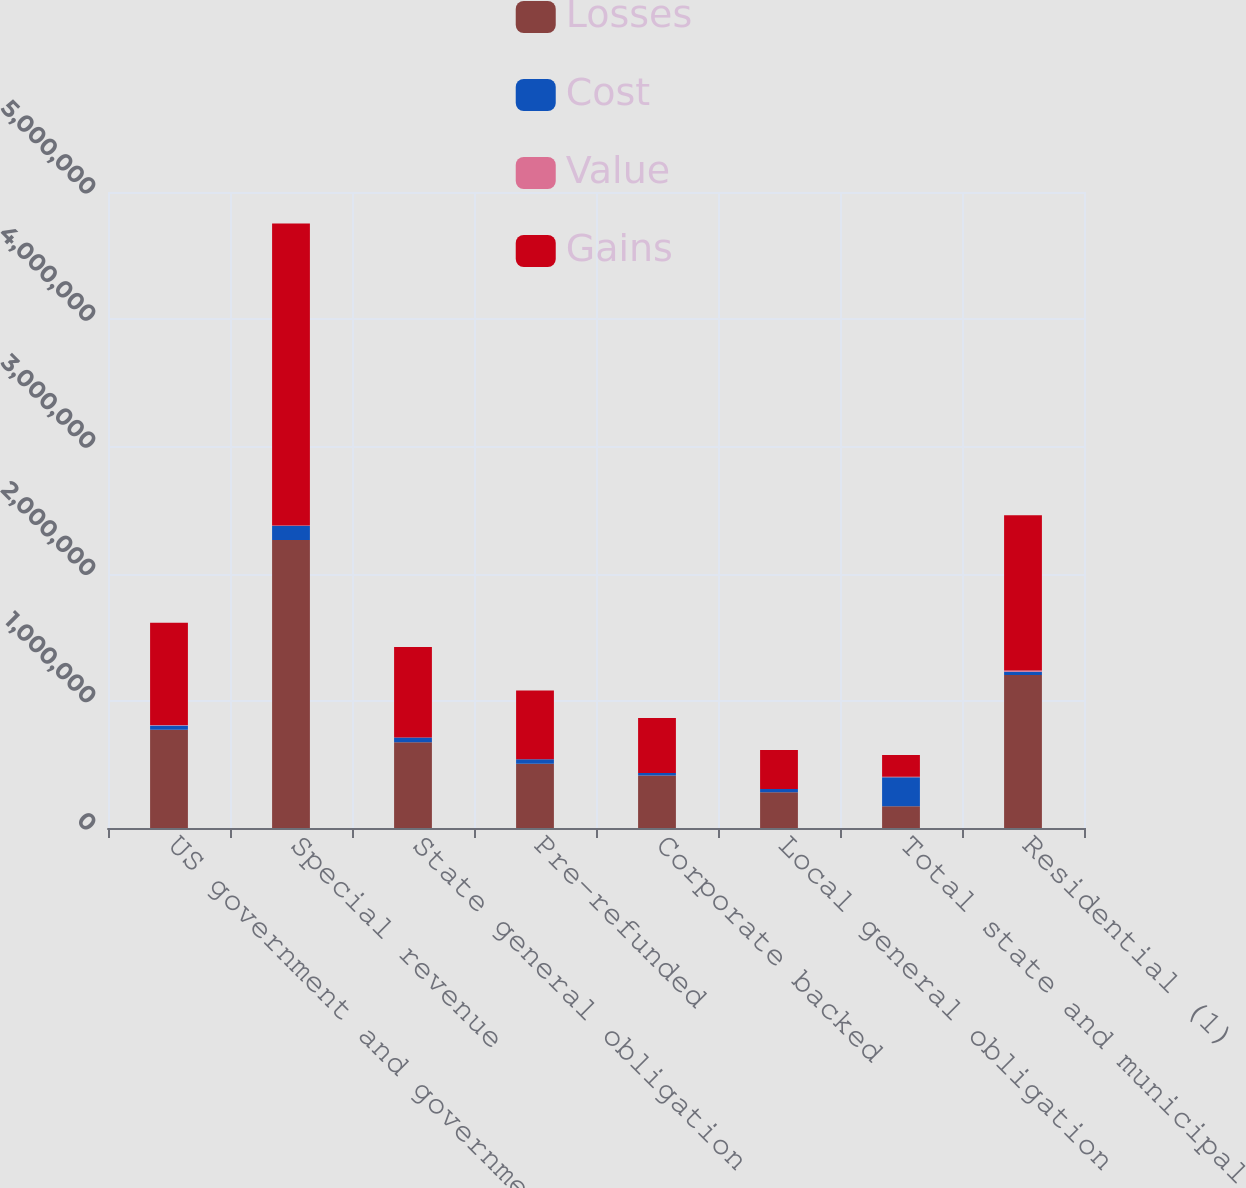Convert chart. <chart><loc_0><loc_0><loc_500><loc_500><stacked_bar_chart><ecel><fcel>US government and government<fcel>Special revenue<fcel>State general obligation<fcel>Pre-refunded<fcel>Corporate backed<fcel>Local general obligation<fcel>Total state and municipal<fcel>Residential (1)<nl><fcel>Losses<fcel>773192<fcel>2.26421e+06<fcel>674022<fcel>504778<fcel>413234<fcel>281622<fcel>170496<fcel>1.20192e+06<nl><fcel>Cost<fcel>33353<fcel>111841<fcel>37615<fcel>35619<fcel>18976<fcel>25099<fcel>229150<fcel>27124<nl><fcel>Value<fcel>3157<fcel>2084<fcel>787<fcel>289<fcel>855<fcel>5<fcel>4020<fcel>9449<nl><fcel>Gains<fcel>803388<fcel>2.37397e+06<fcel>710850<fcel>540108<fcel>431355<fcel>306716<fcel>170496<fcel>1.2196e+06<nl></chart> 